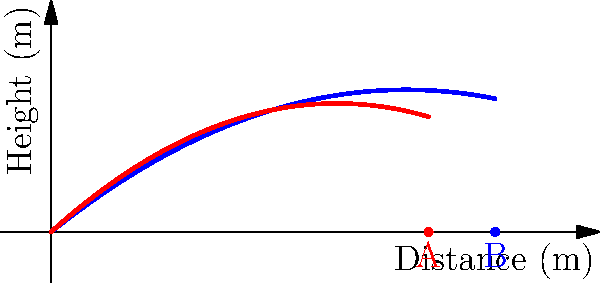A soccer ball is kicked with an initial velocity of 20 m/s at a 45-degree angle. The blue curve shows the ideal trajectory without air resistance, while the red curve represents the actual trajectory with air resistance. If point A represents where the ball lands with air resistance and point B where it would land without air resistance, what is the percentage decrease in the horizontal distance traveled due to air resistance? To solve this problem, we'll follow these steps:

1) First, we need to determine the horizontal distances traveled in both cases:
   - Without air resistance (point B): 10 meters
   - With air resistance (point A): 8.5 meters

2) Calculate the difference in horizontal distance:
   $$\text{Difference} = 10 \text{ m} - 8.5 \text{ m} = 1.5 \text{ m}$$

3) Calculate the percentage decrease:
   $$\text{Percentage decrease} = \frac{\text{Difference}}{\text{Original distance}} \times 100\%$$
   $$= \frac{1.5 \text{ m}}{10 \text{ m}} \times 100\% = 0.15 \times 100\% = 15\%$$

Therefore, the air resistance causes a 15% decrease in the horizontal distance traveled by the soccer ball.
Answer: 15% 